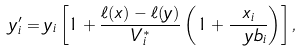Convert formula to latex. <formula><loc_0><loc_0><loc_500><loc_500>y _ { i } ^ { \prime } = y _ { i } \left [ 1 + \frac { \ell ( x ) - \ell ( y ) } { V _ { i } ^ { * } } \left ( 1 + \frac { x _ { i } } { \ y b _ { i } } \right ) \right ] ,</formula> 